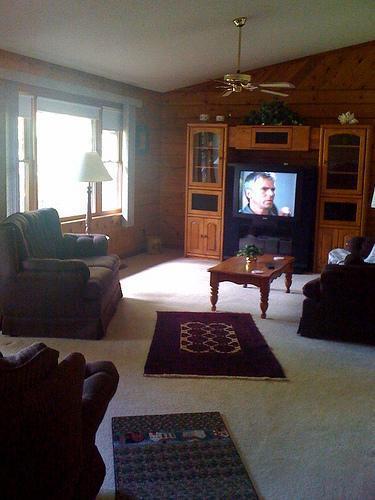How many couches are there?
Give a very brief answer. 3. How many birds are here?
Give a very brief answer. 0. 